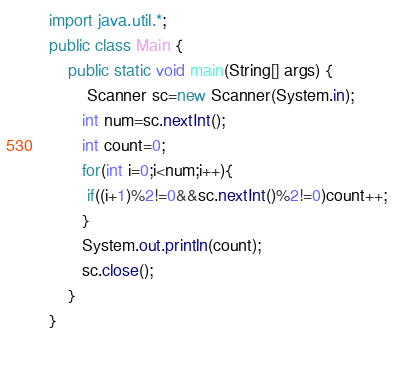<code> <loc_0><loc_0><loc_500><loc_500><_Java_>import java.util.*;
public class Main {
	public static void main(String[] args) {
		Scanner sc=new Scanner(System.in);
       int num=sc.nextInt();
       int count=0;
       for(int i=0;i<num;i++){
        if((i+1)%2!=0&&sc.nextInt()%2!=0)count++;
       }
       System.out.println(count);
       sc.close();
    }
} 

 
</code> 